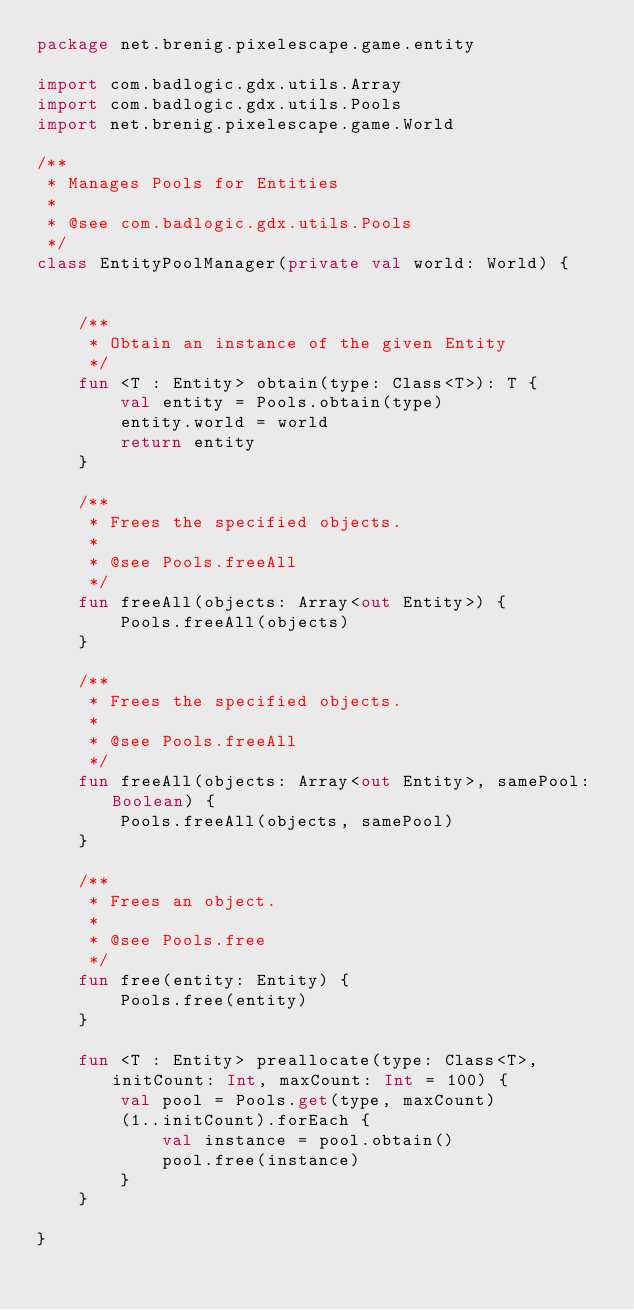<code> <loc_0><loc_0><loc_500><loc_500><_Kotlin_>package net.brenig.pixelescape.game.entity

import com.badlogic.gdx.utils.Array
import com.badlogic.gdx.utils.Pools
import net.brenig.pixelescape.game.World

/**
 * Manages Pools for Entities
 *
 * @see com.badlogic.gdx.utils.Pools
 */
class EntityPoolManager(private val world: World) {


    /**
     * Obtain an instance of the given Entity
     */
    fun <T : Entity> obtain(type: Class<T>): T {
        val entity = Pools.obtain(type)
        entity.world = world
        return entity
    }

    /**
     * Frees the specified objects.
     *
     * @see Pools.freeAll
     */
    fun freeAll(objects: Array<out Entity>) {
        Pools.freeAll(objects)
    }

    /**
     * Frees the specified objects.
     *
     * @see Pools.freeAll
     */
    fun freeAll(objects: Array<out Entity>, samePool: Boolean) {
        Pools.freeAll(objects, samePool)
    }

    /**
     * Frees an object.
     *
     * @see Pools.free
     */
    fun free(entity: Entity) {
        Pools.free(entity)
    }

    fun <T : Entity> preallocate(type: Class<T>, initCount: Int, maxCount: Int = 100) {
        val pool = Pools.get(type, maxCount)
        (1..initCount).forEach {
            val instance = pool.obtain()
            pool.free(instance)
        }
    }

}
</code> 